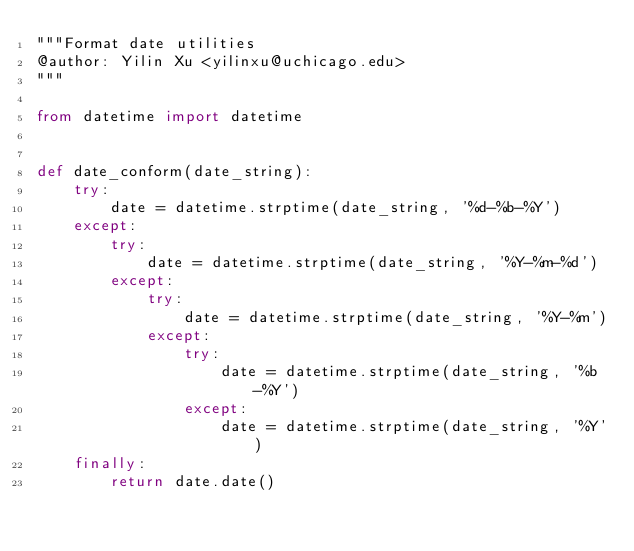Convert code to text. <code><loc_0><loc_0><loc_500><loc_500><_Python_>"""Format date utilities
@author: Yilin Xu <yilinxu@uchicago.edu>
"""

from datetime import datetime


def date_conform(date_string):
    try:
        date = datetime.strptime(date_string, '%d-%b-%Y')
    except:
        try:
            date = datetime.strptime(date_string, '%Y-%m-%d')
        except:
            try:
                date = datetime.strptime(date_string, '%Y-%m')
            except:
                try:
                    date = datetime.strptime(date_string, '%b-%Y')
                except:
                    date = datetime.strptime(date_string, '%Y')
    finally:
        return date.date()
</code> 